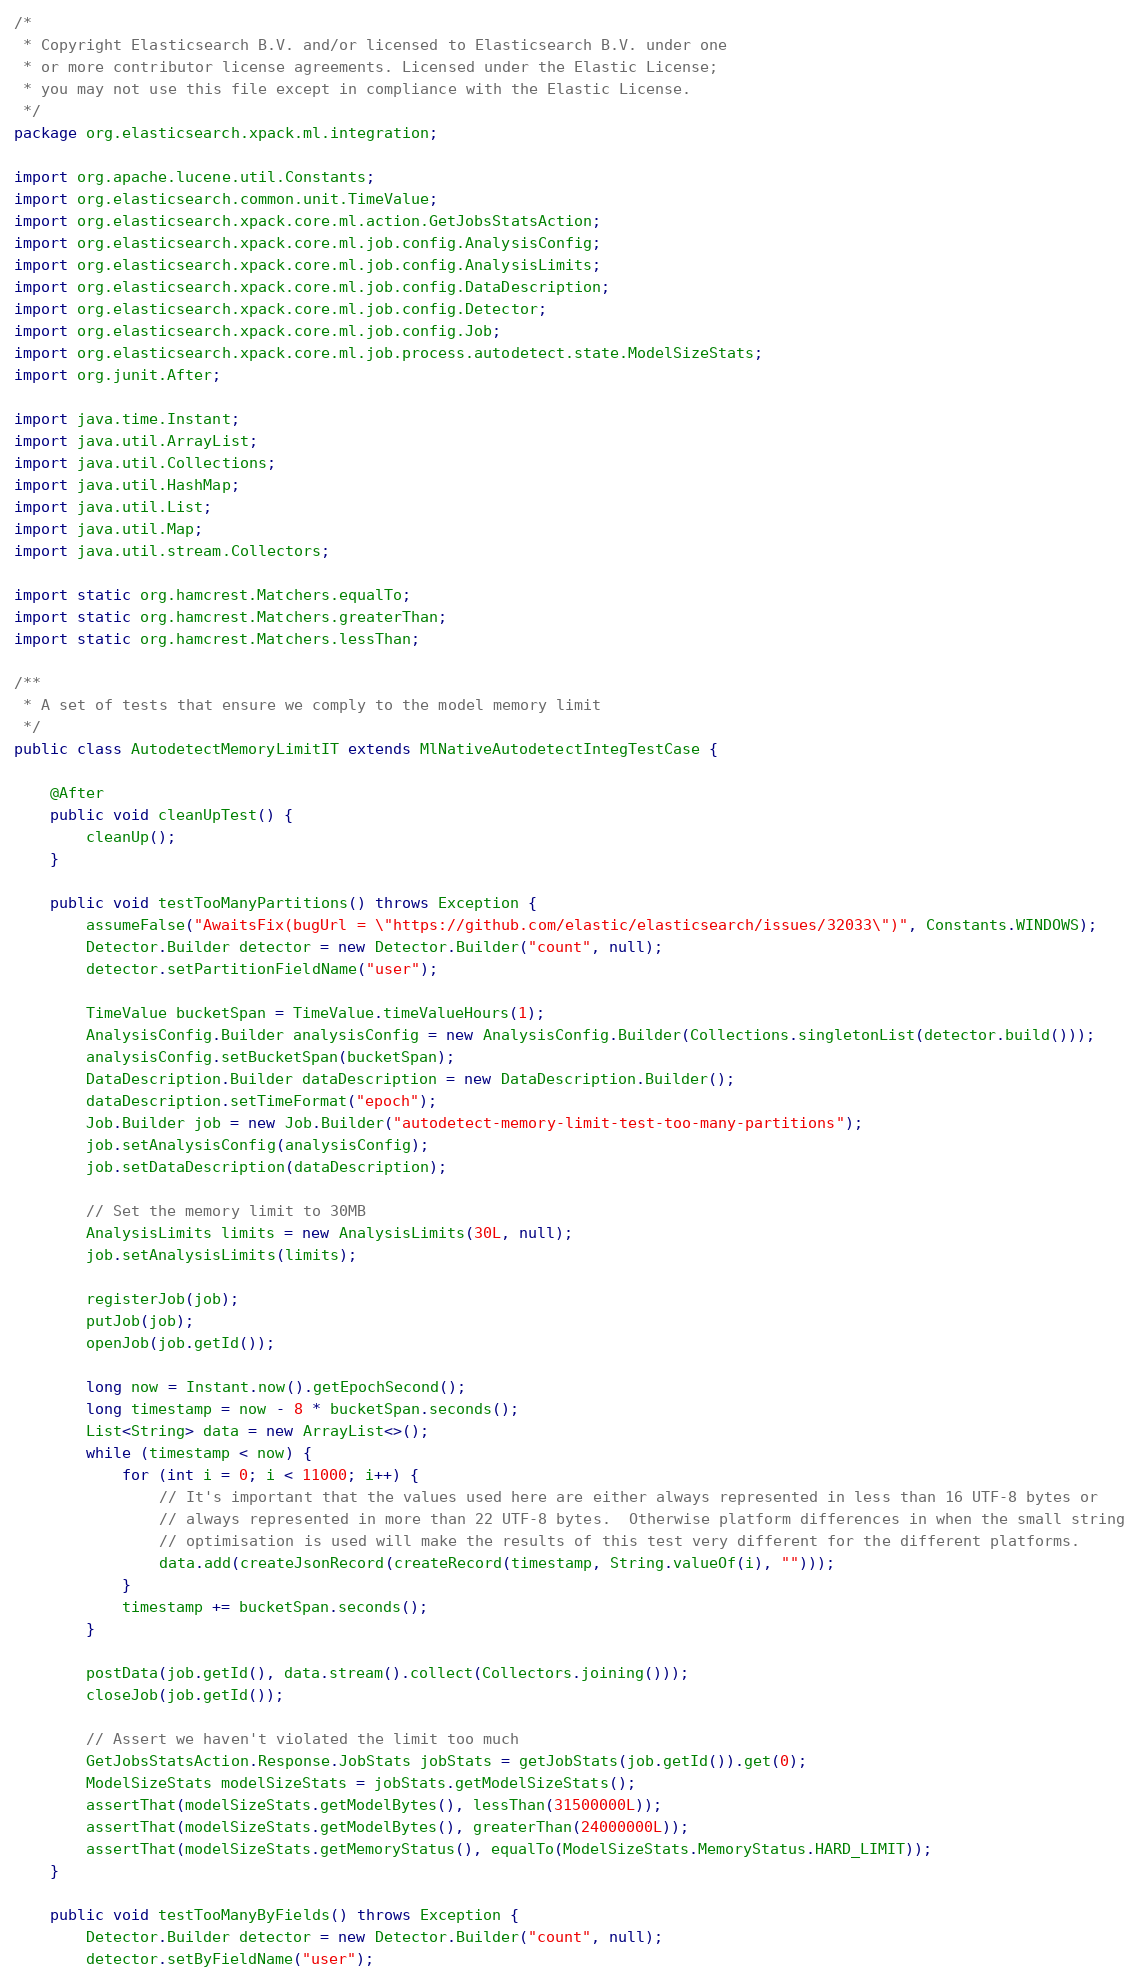Convert code to text. <code><loc_0><loc_0><loc_500><loc_500><_Java_>/*
 * Copyright Elasticsearch B.V. and/or licensed to Elasticsearch B.V. under one
 * or more contributor license agreements. Licensed under the Elastic License;
 * you may not use this file except in compliance with the Elastic License.
 */
package org.elasticsearch.xpack.ml.integration;

import org.apache.lucene.util.Constants;
import org.elasticsearch.common.unit.TimeValue;
import org.elasticsearch.xpack.core.ml.action.GetJobsStatsAction;
import org.elasticsearch.xpack.core.ml.job.config.AnalysisConfig;
import org.elasticsearch.xpack.core.ml.job.config.AnalysisLimits;
import org.elasticsearch.xpack.core.ml.job.config.DataDescription;
import org.elasticsearch.xpack.core.ml.job.config.Detector;
import org.elasticsearch.xpack.core.ml.job.config.Job;
import org.elasticsearch.xpack.core.ml.job.process.autodetect.state.ModelSizeStats;
import org.junit.After;

import java.time.Instant;
import java.util.ArrayList;
import java.util.Collections;
import java.util.HashMap;
import java.util.List;
import java.util.Map;
import java.util.stream.Collectors;

import static org.hamcrest.Matchers.equalTo;
import static org.hamcrest.Matchers.greaterThan;
import static org.hamcrest.Matchers.lessThan;

/**
 * A set of tests that ensure we comply to the model memory limit
 */
public class AutodetectMemoryLimitIT extends MlNativeAutodetectIntegTestCase {

    @After
    public void cleanUpTest() {
        cleanUp();
    }

    public void testTooManyPartitions() throws Exception {
        assumeFalse("AwaitsFix(bugUrl = \"https://github.com/elastic/elasticsearch/issues/32033\")", Constants.WINDOWS);
        Detector.Builder detector = new Detector.Builder("count", null);
        detector.setPartitionFieldName("user");

        TimeValue bucketSpan = TimeValue.timeValueHours(1);
        AnalysisConfig.Builder analysisConfig = new AnalysisConfig.Builder(Collections.singletonList(detector.build()));
        analysisConfig.setBucketSpan(bucketSpan);
        DataDescription.Builder dataDescription = new DataDescription.Builder();
        dataDescription.setTimeFormat("epoch");
        Job.Builder job = new Job.Builder("autodetect-memory-limit-test-too-many-partitions");
        job.setAnalysisConfig(analysisConfig);
        job.setDataDescription(dataDescription);

        // Set the memory limit to 30MB
        AnalysisLimits limits = new AnalysisLimits(30L, null);
        job.setAnalysisLimits(limits);

        registerJob(job);
        putJob(job);
        openJob(job.getId());

        long now = Instant.now().getEpochSecond();
        long timestamp = now - 8 * bucketSpan.seconds();
        List<String> data = new ArrayList<>();
        while (timestamp < now) {
            for (int i = 0; i < 11000; i++) {
                // It's important that the values used here are either always represented in less than 16 UTF-8 bytes or
                // always represented in more than 22 UTF-8 bytes.  Otherwise platform differences in when the small string
                // optimisation is used will make the results of this test very different for the different platforms.
                data.add(createJsonRecord(createRecord(timestamp, String.valueOf(i), "")));
            }
            timestamp += bucketSpan.seconds();
        }

        postData(job.getId(), data.stream().collect(Collectors.joining()));
        closeJob(job.getId());

        // Assert we haven't violated the limit too much
        GetJobsStatsAction.Response.JobStats jobStats = getJobStats(job.getId()).get(0);
        ModelSizeStats modelSizeStats = jobStats.getModelSizeStats();
        assertThat(modelSizeStats.getModelBytes(), lessThan(31500000L));
        assertThat(modelSizeStats.getModelBytes(), greaterThan(24000000L));
        assertThat(modelSizeStats.getMemoryStatus(), equalTo(ModelSizeStats.MemoryStatus.HARD_LIMIT));
    }

    public void testTooManyByFields() throws Exception {
        Detector.Builder detector = new Detector.Builder("count", null);
        detector.setByFieldName("user");
</code> 